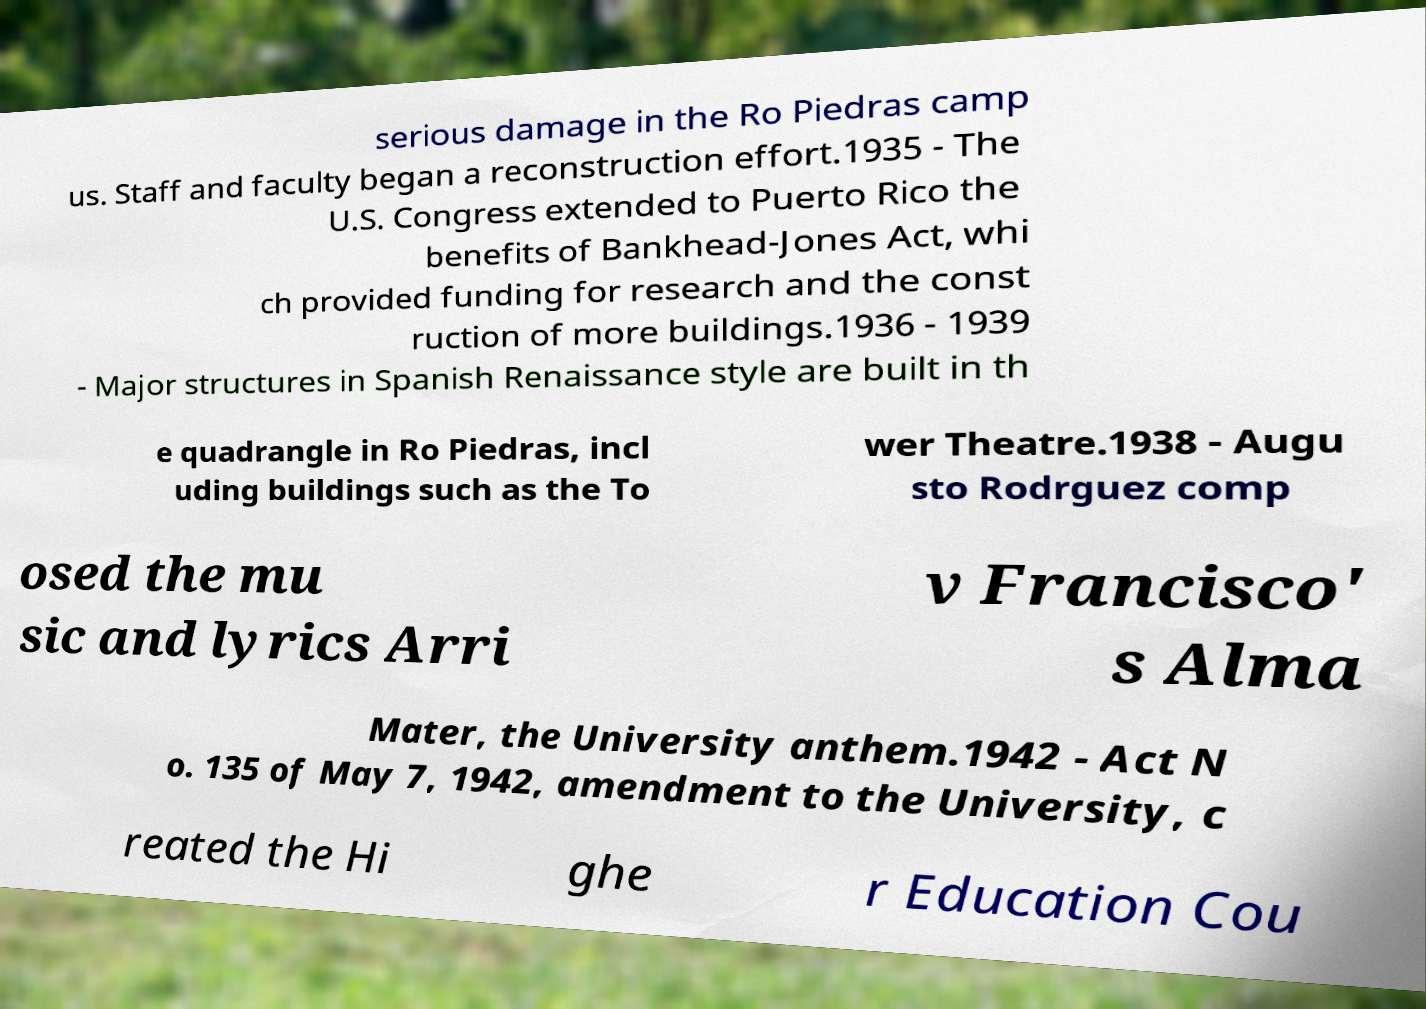Please read and relay the text visible in this image. What does it say? serious damage in the Ro Piedras camp us. Staff and faculty began a reconstruction effort.1935 - The U.S. Congress extended to Puerto Rico the benefits of Bankhead-Jones Act, whi ch provided funding for research and the const ruction of more buildings.1936 - 1939 - Major structures in Spanish Renaissance style are built in th e quadrangle in Ro Piedras, incl uding buildings such as the To wer Theatre.1938 - Augu sto Rodrguez comp osed the mu sic and lyrics Arri v Francisco' s Alma Mater, the University anthem.1942 - Act N o. 135 of May 7, 1942, amendment to the University, c reated the Hi ghe r Education Cou 